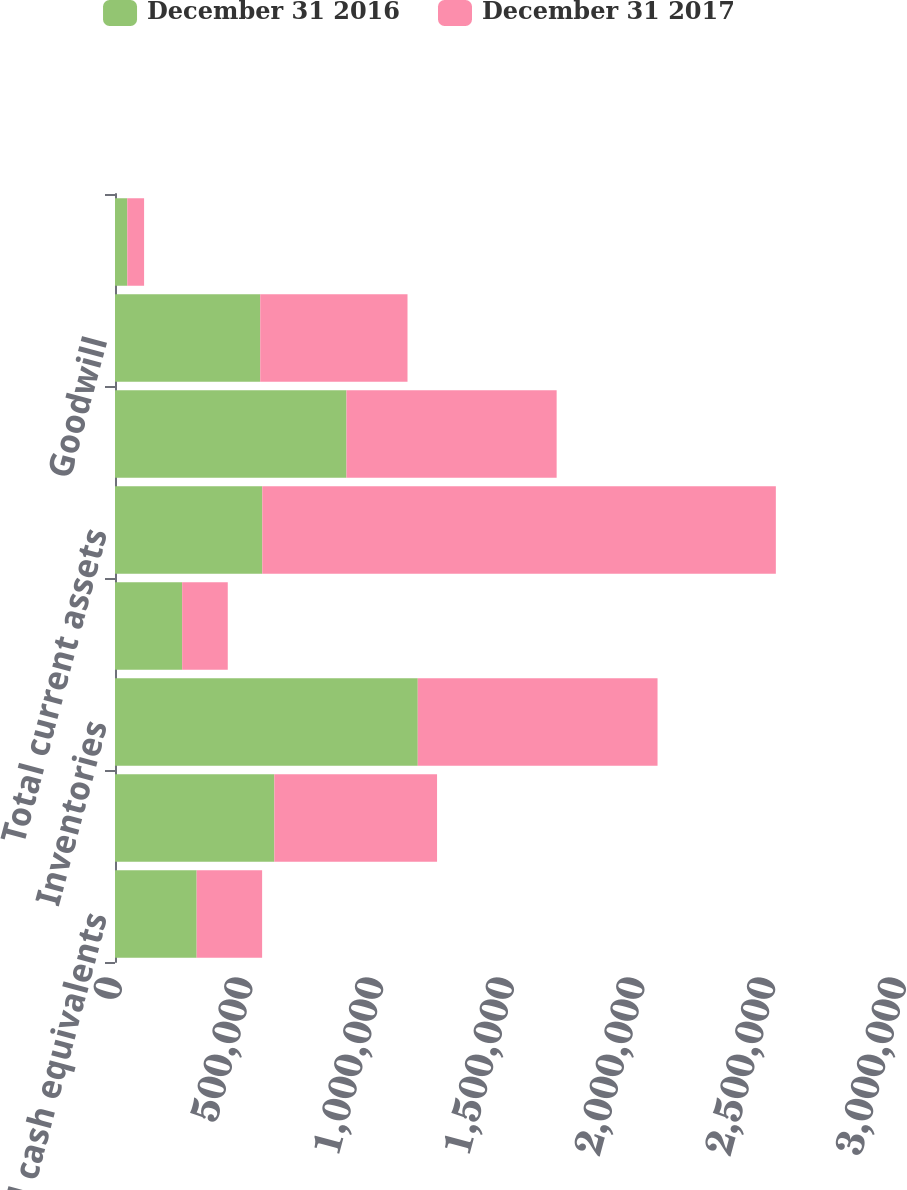Convert chart to OTSL. <chart><loc_0><loc_0><loc_500><loc_500><stacked_bar_chart><ecel><fcel>Cash and cash equivalents<fcel>Accounts receivable net<fcel>Inventories<fcel>Prepaid expenses and other<fcel>Total current assets<fcel>Property and equipment net<fcel>Goodwill<fcel>Intangible assets net<nl><fcel>December 31 2016<fcel>312483<fcel>609670<fcel>1.15855e+06<fcel>256978<fcel>563591<fcel>885774<fcel>555674<fcel>46995<nl><fcel>December 31 2017<fcel>250470<fcel>622685<fcel>917491<fcel>174507<fcel>1.96515e+06<fcel>804211<fcel>563591<fcel>64310<nl></chart> 